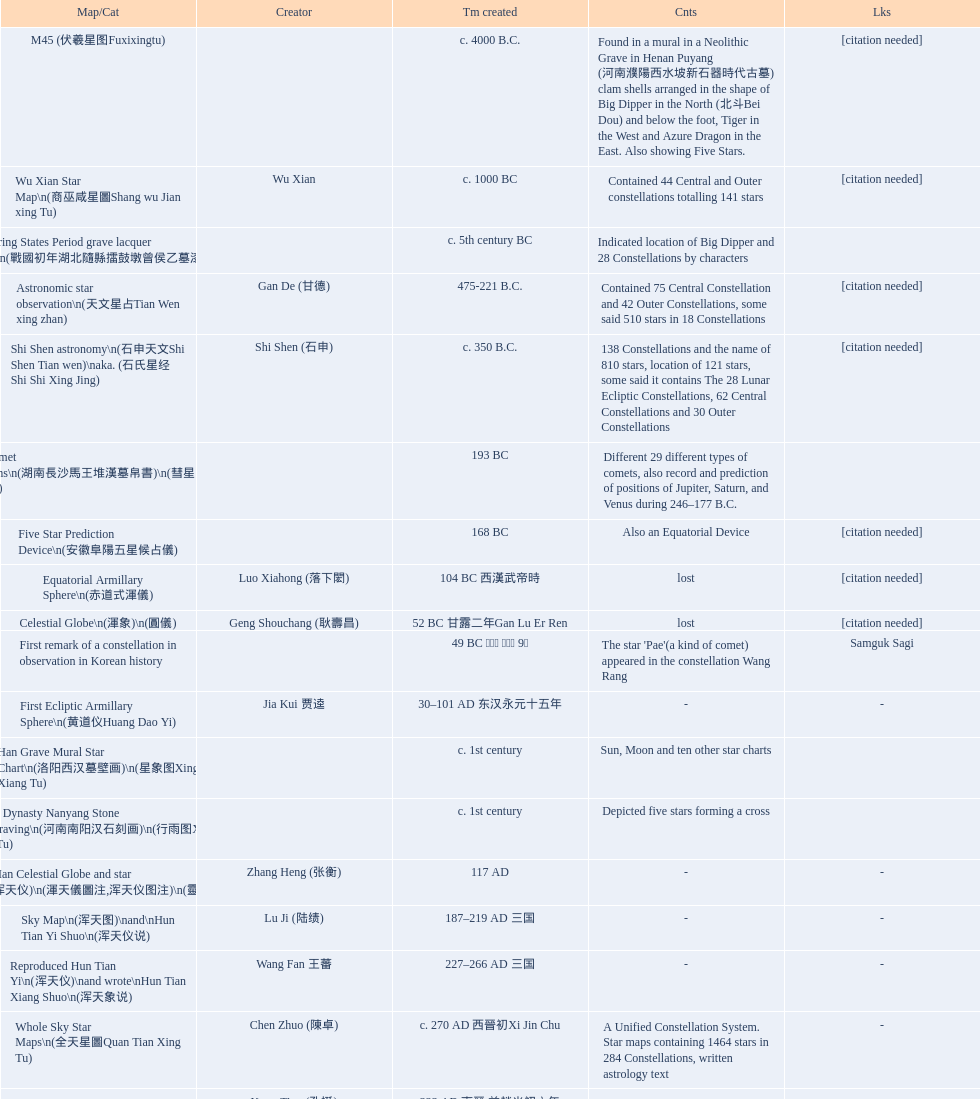When was the first map or catalog created? C. 4000 b.c. 